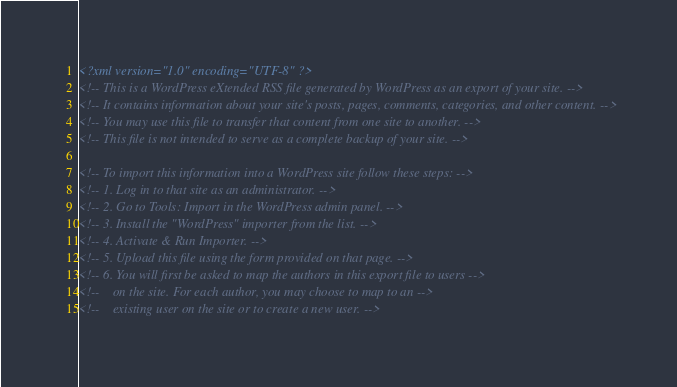<code> <loc_0><loc_0><loc_500><loc_500><_XML_><?xml version="1.0" encoding="UTF-8" ?>
<!-- This is a WordPress eXtended RSS file generated by WordPress as an export of your site. -->
<!-- It contains information about your site's posts, pages, comments, categories, and other content. -->
<!-- You may use this file to transfer that content from one site to another. -->
<!-- This file is not intended to serve as a complete backup of your site. -->

<!-- To import this information into a WordPress site follow these steps: -->
<!-- 1. Log in to that site as an administrator. -->
<!-- 2. Go to Tools: Import in the WordPress admin panel. -->
<!-- 3. Install the "WordPress" importer from the list. -->
<!-- 4. Activate & Run Importer. -->
<!-- 5. Upload this file using the form provided on that page. -->
<!-- 6. You will first be asked to map the authors in this export file to users -->
<!--    on the site. For each author, you may choose to map to an -->
<!--    existing user on the site or to create a new user. --></code> 